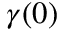Convert formula to latex. <formula><loc_0><loc_0><loc_500><loc_500>\gamma ( 0 )</formula> 